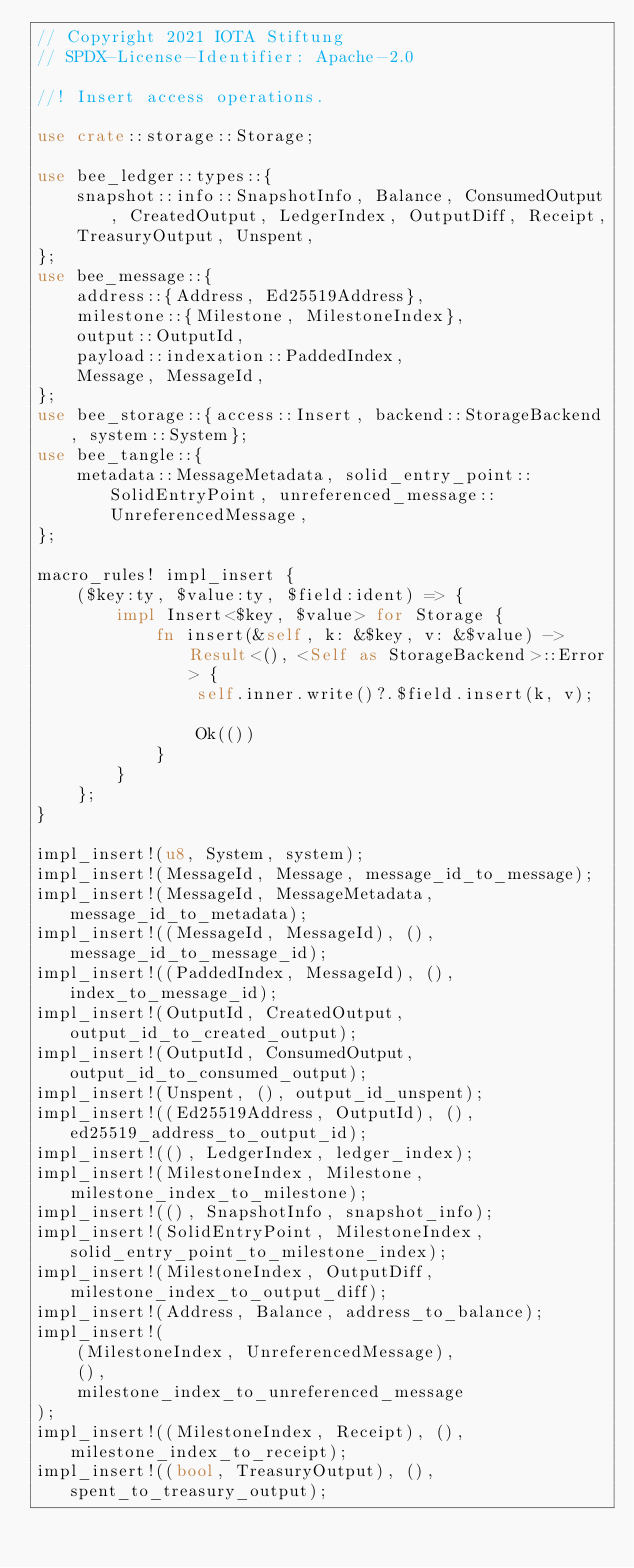Convert code to text. <code><loc_0><loc_0><loc_500><loc_500><_Rust_>// Copyright 2021 IOTA Stiftung
// SPDX-License-Identifier: Apache-2.0

//! Insert access operations.

use crate::storage::Storage;

use bee_ledger::types::{
    snapshot::info::SnapshotInfo, Balance, ConsumedOutput, CreatedOutput, LedgerIndex, OutputDiff, Receipt,
    TreasuryOutput, Unspent,
};
use bee_message::{
    address::{Address, Ed25519Address},
    milestone::{Milestone, MilestoneIndex},
    output::OutputId,
    payload::indexation::PaddedIndex,
    Message, MessageId,
};
use bee_storage::{access::Insert, backend::StorageBackend, system::System};
use bee_tangle::{
    metadata::MessageMetadata, solid_entry_point::SolidEntryPoint, unreferenced_message::UnreferencedMessage,
};

macro_rules! impl_insert {
    ($key:ty, $value:ty, $field:ident) => {
        impl Insert<$key, $value> for Storage {
            fn insert(&self, k: &$key, v: &$value) -> Result<(), <Self as StorageBackend>::Error> {
                self.inner.write()?.$field.insert(k, v);

                Ok(())
            }
        }
    };
}

impl_insert!(u8, System, system);
impl_insert!(MessageId, Message, message_id_to_message);
impl_insert!(MessageId, MessageMetadata, message_id_to_metadata);
impl_insert!((MessageId, MessageId), (), message_id_to_message_id);
impl_insert!((PaddedIndex, MessageId), (), index_to_message_id);
impl_insert!(OutputId, CreatedOutput, output_id_to_created_output);
impl_insert!(OutputId, ConsumedOutput, output_id_to_consumed_output);
impl_insert!(Unspent, (), output_id_unspent);
impl_insert!((Ed25519Address, OutputId), (), ed25519_address_to_output_id);
impl_insert!((), LedgerIndex, ledger_index);
impl_insert!(MilestoneIndex, Milestone, milestone_index_to_milestone);
impl_insert!((), SnapshotInfo, snapshot_info);
impl_insert!(SolidEntryPoint, MilestoneIndex, solid_entry_point_to_milestone_index);
impl_insert!(MilestoneIndex, OutputDiff, milestone_index_to_output_diff);
impl_insert!(Address, Balance, address_to_balance);
impl_insert!(
    (MilestoneIndex, UnreferencedMessage),
    (),
    milestone_index_to_unreferenced_message
);
impl_insert!((MilestoneIndex, Receipt), (), milestone_index_to_receipt);
impl_insert!((bool, TreasuryOutput), (), spent_to_treasury_output);
</code> 